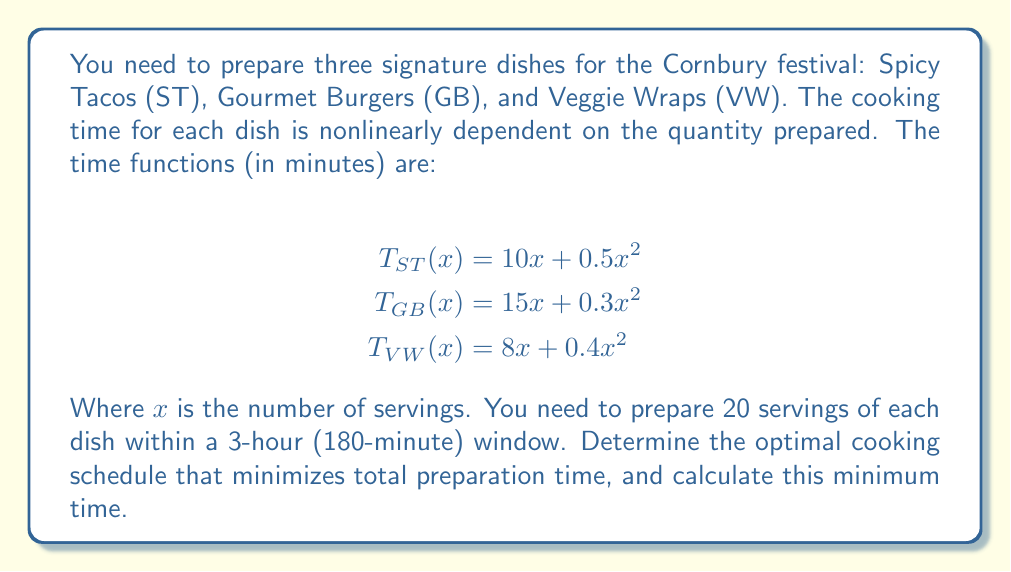Provide a solution to this math problem. To solve this nonlinear scheduling problem, we'll use the method of Lagrange multipliers:

1) Define the objective function:
   $$f(x,y,z) = (10x + 0.5x^2) + (15y + 0.3y^2) + (8z + 0.4z^2)$$
   where x, y, and z are the number of servings of ST, GB, and VW respectively.

2) Define the constraint:
   $$g(x,y,z) = x + y + z - 20 = 0$$

3) Form the Lagrangian:
   $$L(x,y,z,λ) = f(x,y,z) - λg(x,y,z)$$

4) Set partial derivatives to zero:
   $$\frac{\partial L}{\partial x} = 10 + x - λ = 0$$
   $$\frac{\partial L}{\partial y} = 15 + 0.6y - λ = 0$$
   $$\frac{\partial L}{\partial z} = 8 + 0.8z - λ = 0$$
   $$\frac{\partial L}{\partial λ} = x + y + z - 20 = 0$$

5) Solve the system of equations:
   From the first three equations:
   $$x = λ - 10$$
   $$y = \frac{5}{3}(λ - 15)$$
   $$z = \frac{5}{4}(λ - 8)$$

   Substituting into the fourth equation:
   $$(λ - 10) + \frac{5}{3}(λ - 15) + \frac{5}{4}(λ - 8) = 20$$

   Solving for λ: λ ≈ 22.76

6) Substituting back:
   $$x ≈ 12.76$$
   $$y ≈ 6.46$$
   $$z ≈ 0.78$$

7) Rounding to nearest whole numbers (as we can't prepare partial servings):
   x = 13 (ST), y = 6 (GB), z = 1 (VW)

8) Calculate the minimum time:
   $$T_{min} = (10(13) + 0.5(13^2)) + (15(6) + 0.3(6^2)) + (8(1) + 0.4(1^2))$$
   $$= (130 + 84.5) + (90 + 10.8) + (8 + 0.4)$$
   $$= 214.5 + 100.8 + 8.4 = 323.7 \text{ minutes}$$
Answer: Optimal schedule: 13 ST, 6 GB, 1 VW. Minimum time: 323.7 minutes. 